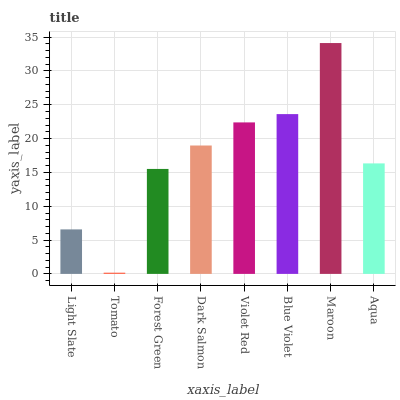Is Tomato the minimum?
Answer yes or no. Yes. Is Maroon the maximum?
Answer yes or no. Yes. Is Forest Green the minimum?
Answer yes or no. No. Is Forest Green the maximum?
Answer yes or no. No. Is Forest Green greater than Tomato?
Answer yes or no. Yes. Is Tomato less than Forest Green?
Answer yes or no. Yes. Is Tomato greater than Forest Green?
Answer yes or no. No. Is Forest Green less than Tomato?
Answer yes or no. No. Is Dark Salmon the high median?
Answer yes or no. Yes. Is Aqua the low median?
Answer yes or no. Yes. Is Violet Red the high median?
Answer yes or no. No. Is Light Slate the low median?
Answer yes or no. No. 